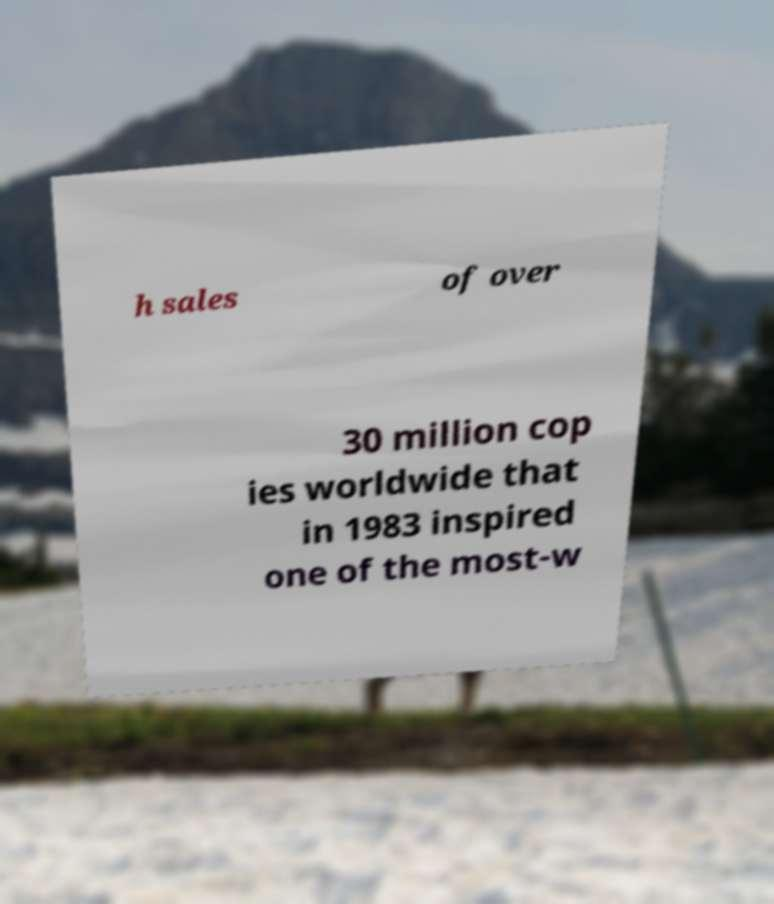Could you extract and type out the text from this image? h sales of over 30 million cop ies worldwide that in 1983 inspired one of the most-w 